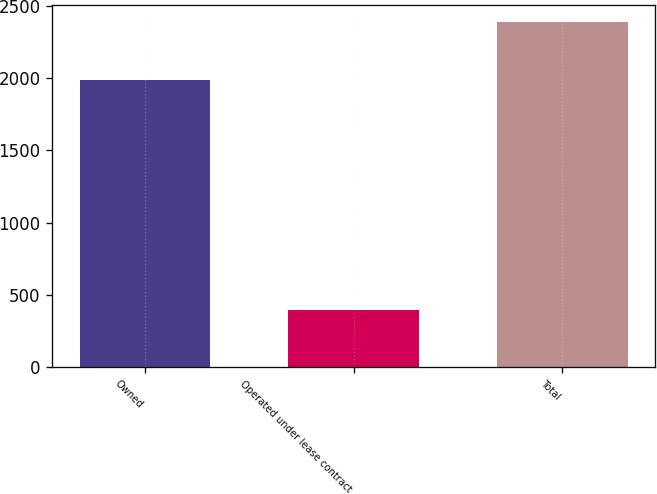<chart> <loc_0><loc_0><loc_500><loc_500><bar_chart><fcel>Owned<fcel>Operated under lease contract<fcel>Total<nl><fcel>1989<fcel>397<fcel>2386<nl></chart> 